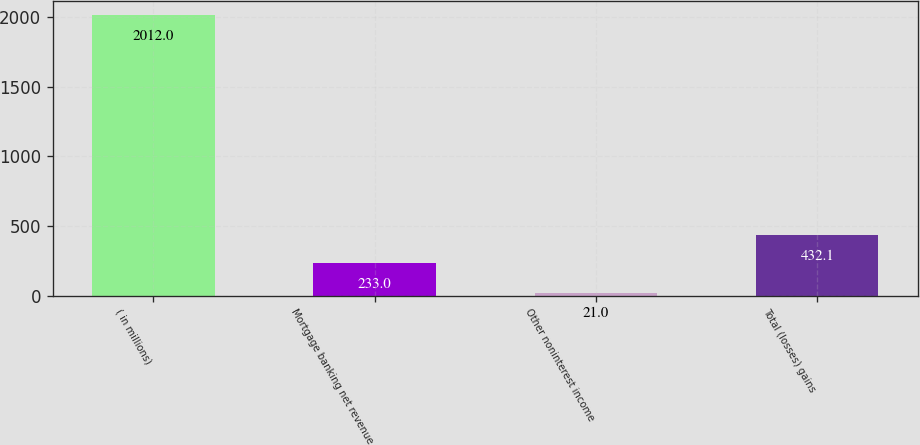Convert chart. <chart><loc_0><loc_0><loc_500><loc_500><bar_chart><fcel>( in millions)<fcel>Mortgage banking net revenue<fcel>Other noninterest income<fcel>Total (losses) gains<nl><fcel>2012<fcel>233<fcel>21<fcel>432.1<nl></chart> 